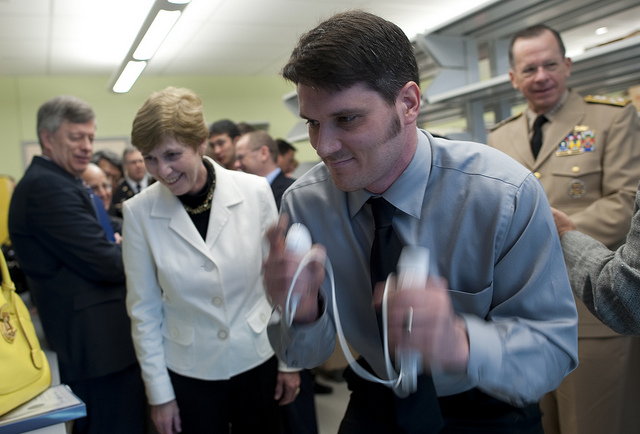Are there other objects on the table that provide context about the event? There are various objects on the table, which seem to be part of a demonstration. However, the details are not clearly visible in this image, making it difficult to draw specific conclusions about their purpose. 